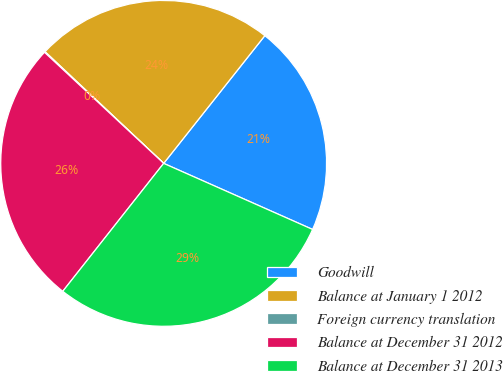Convert chart to OTSL. <chart><loc_0><loc_0><loc_500><loc_500><pie_chart><fcel>Goodwill<fcel>Balance at January 1 2012<fcel>Foreign currency translation<fcel>Balance at December 31 2012<fcel>Balance at December 31 2013<nl><fcel>20.98%<fcel>23.64%<fcel>0.08%<fcel>26.31%<fcel>28.98%<nl></chart> 